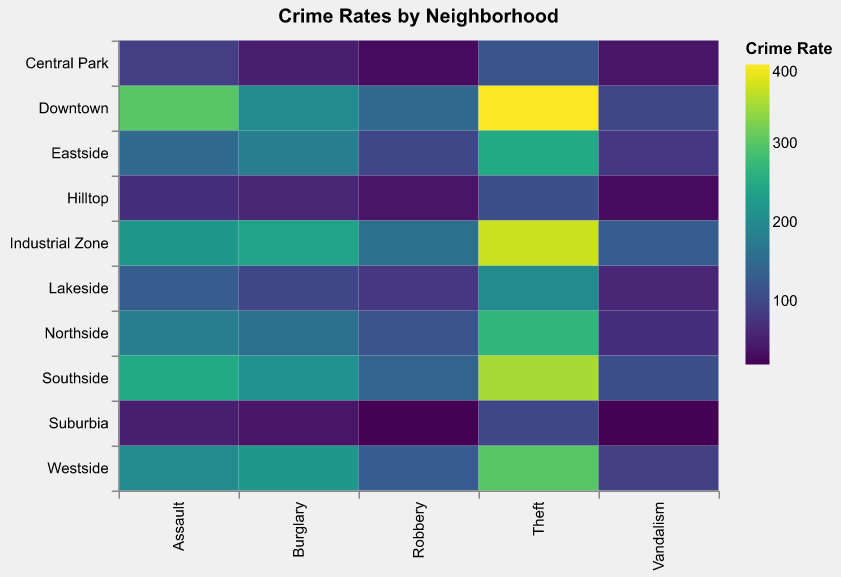What is the title of the figure? The title of the figure is displayed at the top. It reads, "Crime Rates by Neighborhood".
Answer: Crime Rates by Neighborhood Which neighborhood has the highest rate of Assault? By looking at the color intensity in the Assault column, the darkest color represents the highest rate. Downtown has the darkest color there.
Answer: Downtown What's the total number of crimes reported in Suburbia? Sum the numbers for all crime types in Suburbia. That is, 50 (Assault) + 40 (Burglary) + 20 (Robbery) + 100 (Theft) + 20 (Vandalism) = 230.
Answer: 230 How does the rate of Burglary in Northside compare to Southside? Look at the Burglary column and compare the colors for Northside and Southside. Northside has a lighter color indicating a lower rate. Southside is darker indicating a higher rate.
Answer: Southside has a higher rate Which neighborhood has the lowest rate of Theft? By examining the color intensities in the Theft column, the neighborhood with the lightest color represents the lowest rate. Central Park appears to have the lightest color there.
Answer: Central Park What's the average rate of Vandalism across all neighborhoods? Add together the rates of Vandalism for each neighborhood then divide by 10 (the total number of neighborhoods): (100+80+90+70+110+40+60+30+20+130)/10 = 73
Answer: 73 Compare the total number of crimes in Downtown to Industrial Zone. Which one is higher? Sum the numbers for all crime types in each neighborhood:
Downtown: 300+200+150+400+100 = 1150
Industrial Zone: 220+240+160+370+130 = 1120.
Downtown has a higher total.
Answer: Downtown Which three neighborhoods have the highest rates of Burglary? Using the Burglary column, identify the three neighborhoods with the darkest colors. They are Industrial Zone, Westside, and Southside.
Answer: Industrial Zone, Westside, Southside What's the average rate of Assault in the neighborhoods with more than 200 Burglary cases? First, identify the neighborhoods with more than 200 Burglary cases: Downtown, Westside, Southside, Industrial Zone. Add their Assault rates: 300+200+250+220 = 970. Then divide by 4: 970/4 = 242.5.
Answer: 242.5 Which crime type has the highest reported rate overall? Identify the darkest color in the entire heatmap, which represents the highest rate. It is found in the Theft column for Downtown with 400 cases.
Answer: Theft 